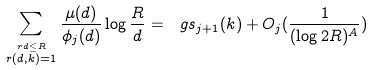Convert formula to latex. <formula><loc_0><loc_0><loc_500><loc_500>\sum _ { \stackrel { r d \leq R } { r ( d , k ) = 1 } } \frac { \mu ( d ) } { \phi _ { j } ( d ) } \log \frac { R } { d } = \ g s _ { j + 1 } ( k ) + O _ { j } ( \frac { 1 } { ( \log 2 R ) ^ { A } } )</formula> 